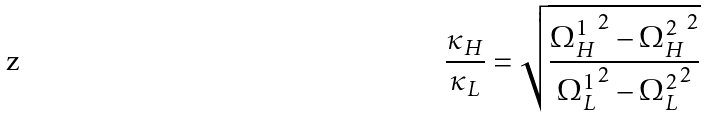<formula> <loc_0><loc_0><loc_500><loc_500>\frac { \kappa _ { H } } { \kappa _ { L } } = \sqrt { \frac { { \Omega ^ { 1 } _ { H } } ^ { 2 } - { \Omega ^ { 2 } _ { H } } ^ { 2 } } { { \Omega ^ { 1 } _ { L } } ^ { 2 } - { \Omega ^ { 2 } _ { L } } ^ { 2 } } }</formula> 